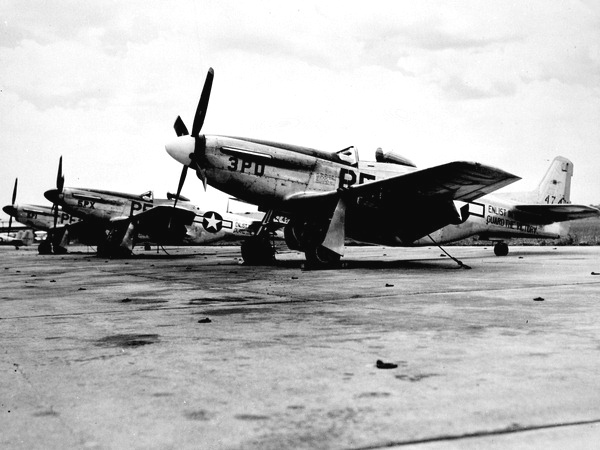How many towers have clocks on them? In the image provided, there are no towers featuring clocks. The photograph captures historical aircraft, specifically P-51 Mustangs, lined up on an airfield during what appears to be a period of military activity, possibly during World War II. These planes are distinguished by their single propellers and the characteristic airframe design used by American forces in that era. 